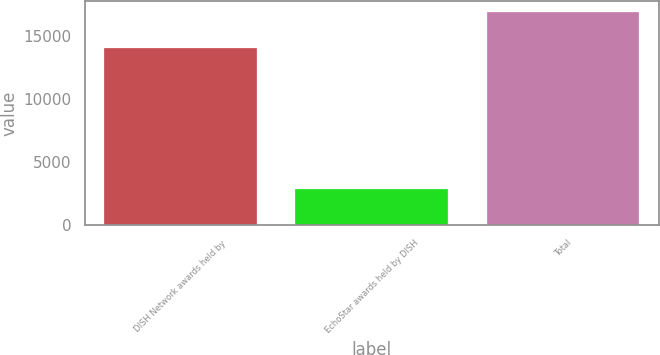Convert chart to OTSL. <chart><loc_0><loc_0><loc_500><loc_500><bar_chart><fcel>DISH Network awards held by<fcel>EchoStar awards held by DISH<fcel>Total<nl><fcel>14052<fcel>2853<fcel>16905<nl></chart> 